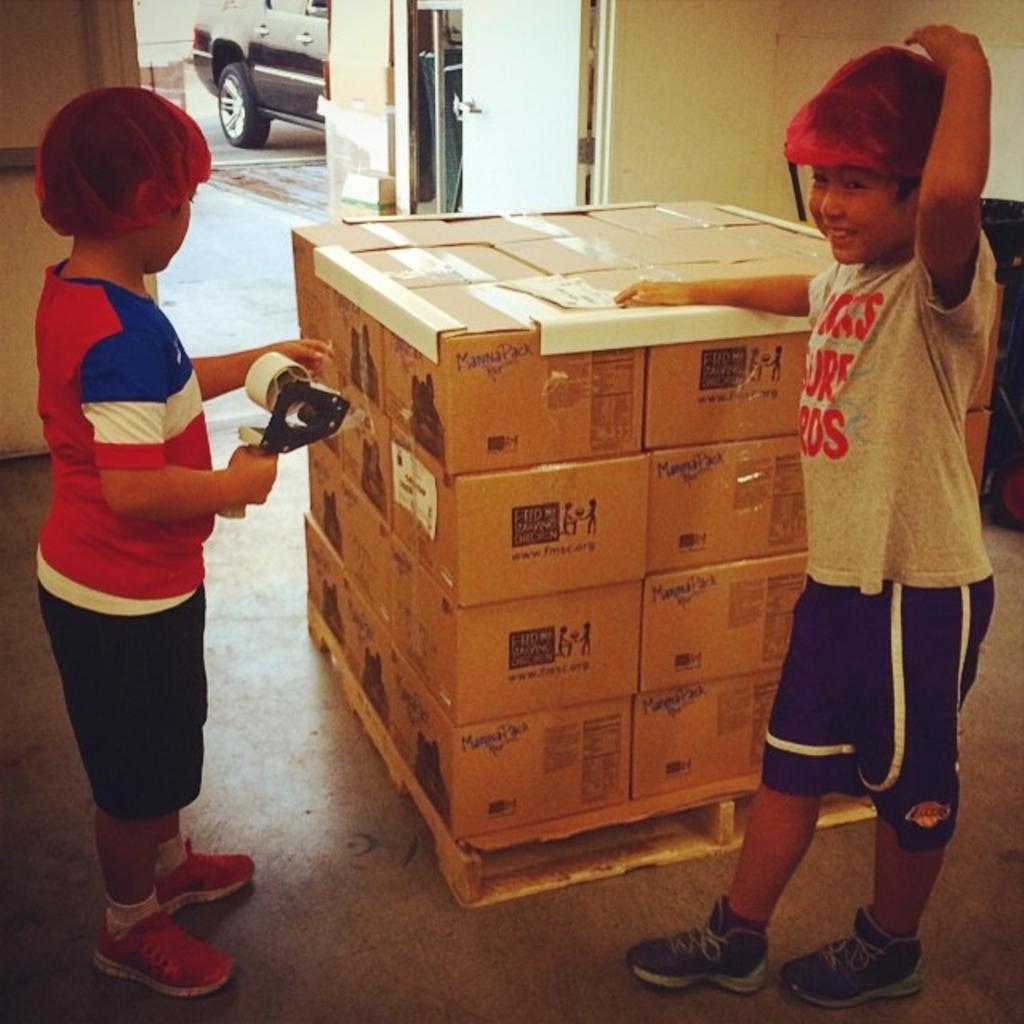Could you give a brief overview of what you see in this image? In this image there are two boys standing near boxes, a boy is holding a tape in his hand, in the background there is a wall, for that wall there is a door through that door a car is visible. 